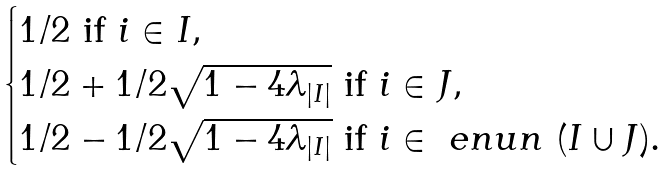Convert formula to latex. <formula><loc_0><loc_0><loc_500><loc_500>\begin{cases} 1 / 2 \text { if } i \in I , \\ 1 / 2 + 1 / 2 \sqrt { 1 - 4 \lambda _ { | I | } } \text { if } i \in J , \\ 1 / 2 - 1 / 2 \sqrt { 1 - 4 \lambda _ { | I | } } \text { if } i \in \ e n u { n } \ ( I \cup J ) . \end{cases}</formula> 